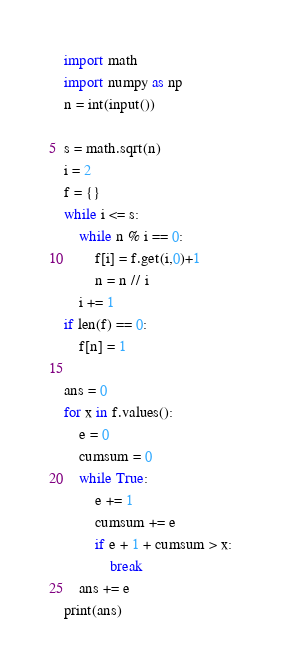<code> <loc_0><loc_0><loc_500><loc_500><_Python_>import math
import numpy as np
n = int(input())

s = math.sqrt(n)
i = 2
f = {}
while i <= s:
    while n % i == 0:
        f[i] = f.get(i,0)+1
        n = n // i
    i += 1
if len(f) == 0:
    f[n] = 1

ans = 0
for x in f.values():
    e = 0
    cumsum = 0
    while True:
        e += 1
        cumsum += e
        if e + 1 + cumsum > x:
            break
    ans += e
print(ans)</code> 